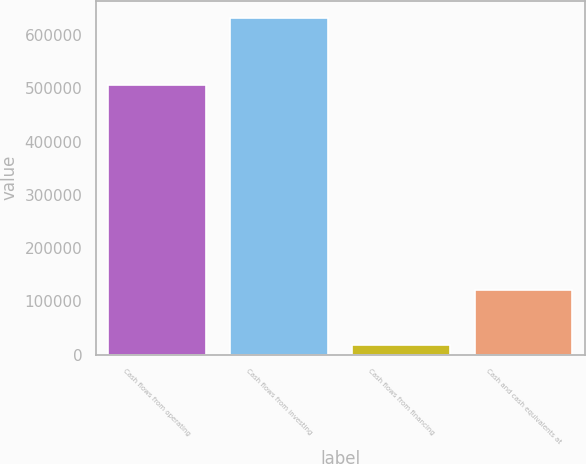Convert chart to OTSL. <chart><loc_0><loc_0><loc_500><loc_500><bar_chart><fcel>Cash flows from operating<fcel>Cash flows from investing<fcel>Cash flows from financing<fcel>Cash and cash equivalents at<nl><fcel>506593<fcel>632750<fcel>18564<fcel>120526<nl></chart> 